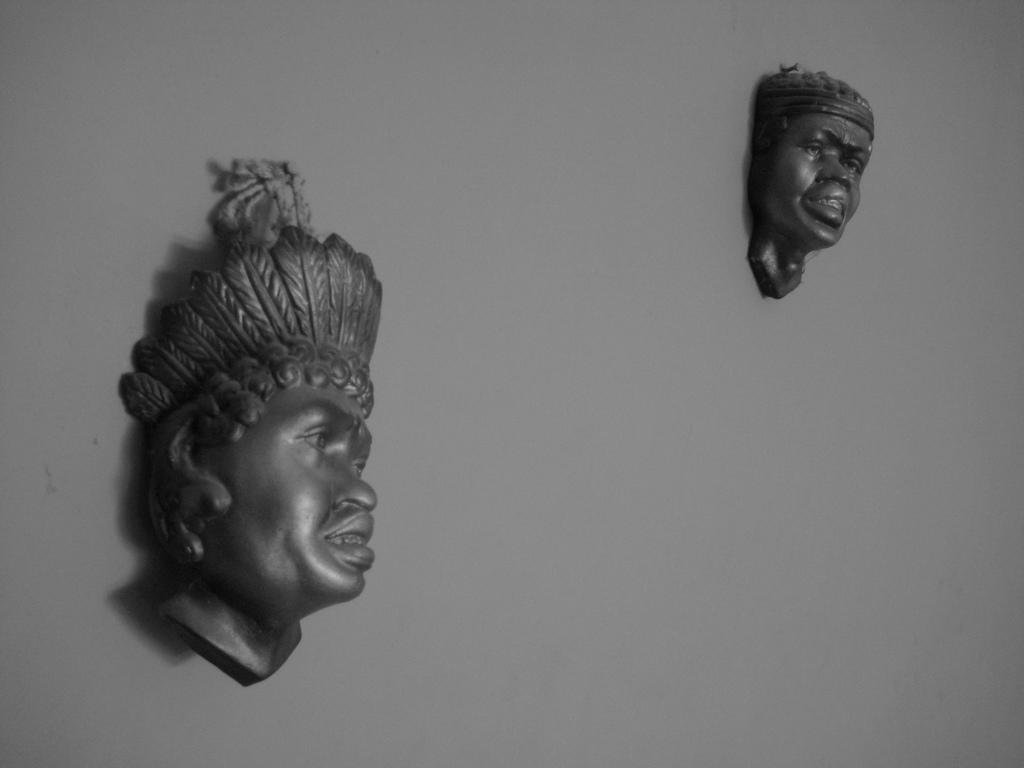What is the main feature in the center of the image? There is a wall in the center of the image. What can be seen on the wall? There are idols on the wall. Are there any dinosaurs visible in the image? No, there are no dinosaurs present in the image. Can you tell me how many doors are on the wall in the image? There is no door visible on the wall in the image; only idols are present. 